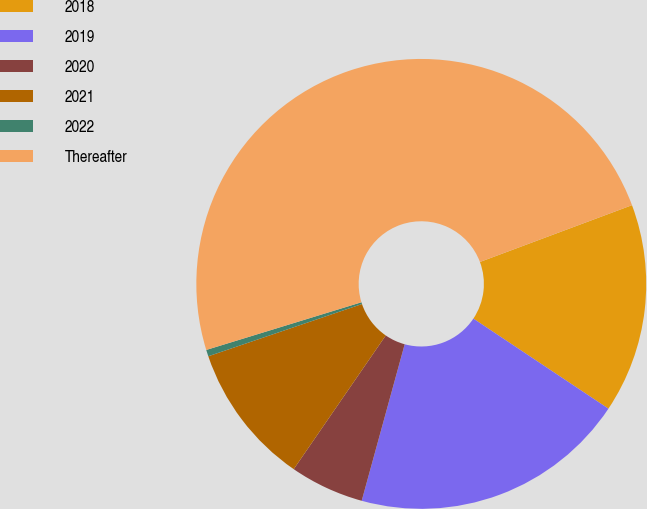Convert chart. <chart><loc_0><loc_0><loc_500><loc_500><pie_chart><fcel>2018<fcel>2019<fcel>2020<fcel>2021<fcel>2022<fcel>Thereafter<nl><fcel>15.05%<fcel>19.91%<fcel>5.33%<fcel>10.19%<fcel>0.47%<fcel>49.06%<nl></chart> 